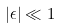Convert formula to latex. <formula><loc_0><loc_0><loc_500><loc_500>| \epsilon | \ll 1</formula> 